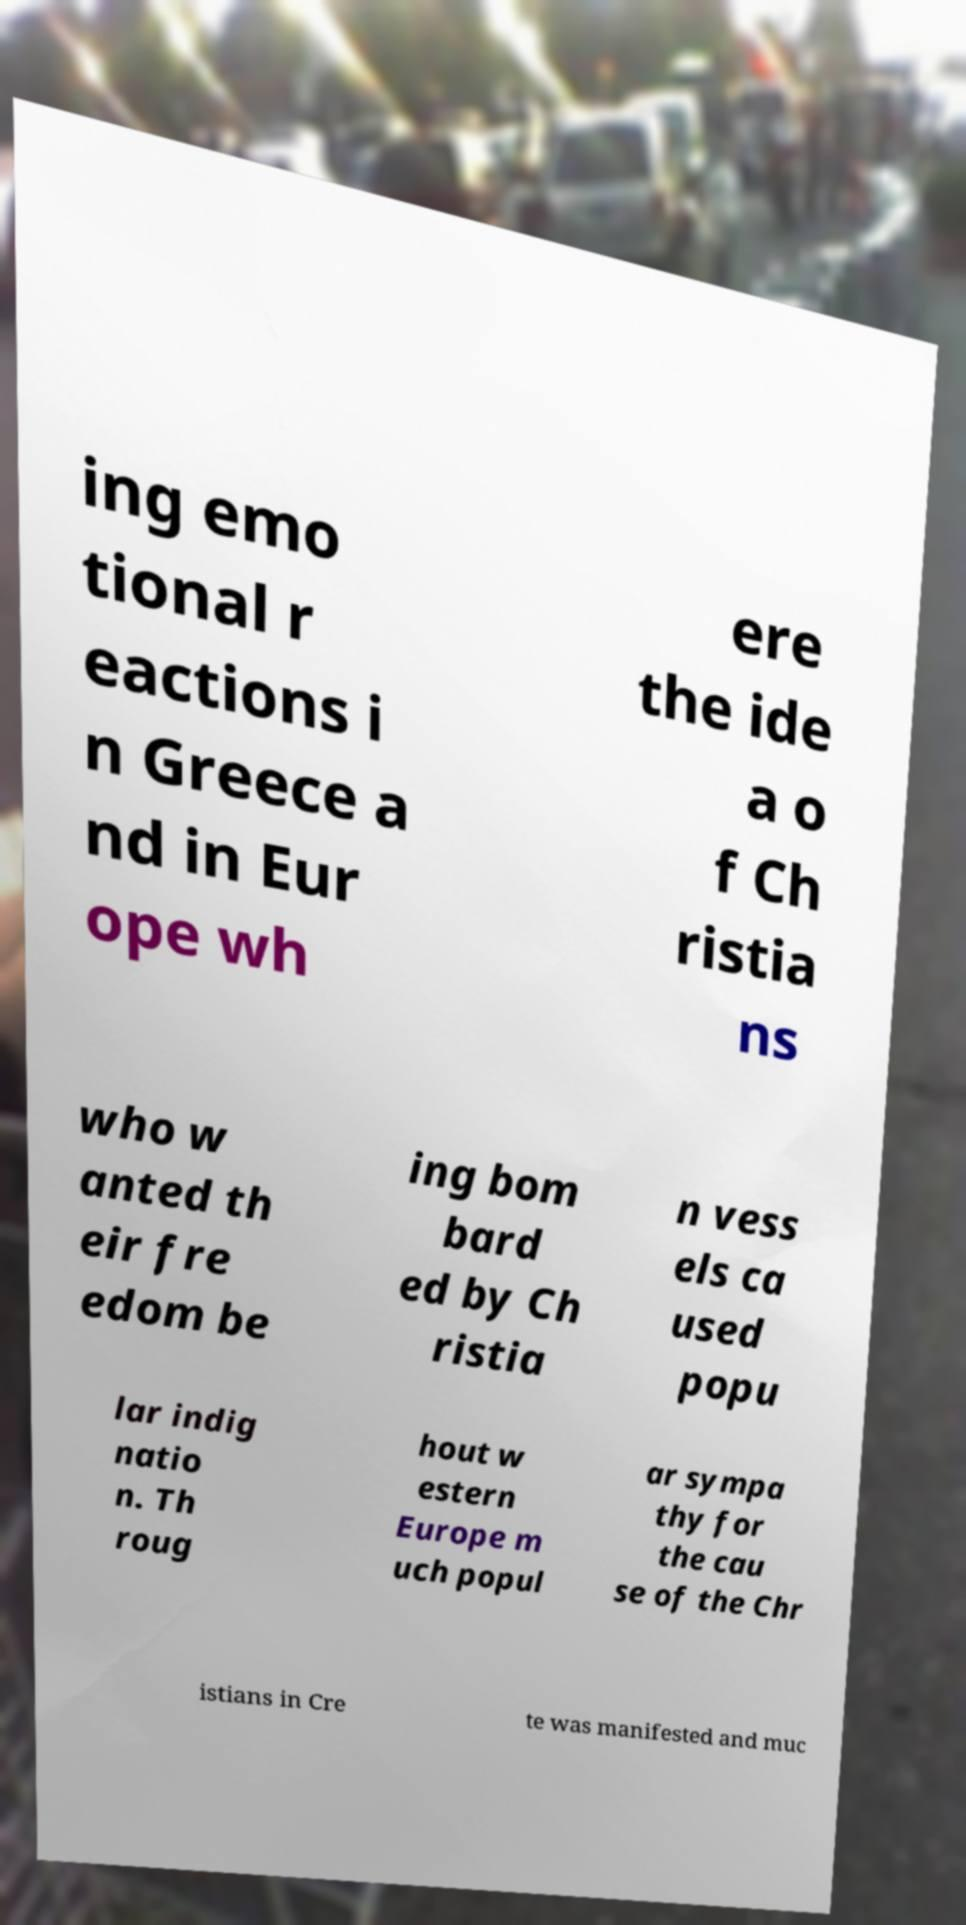There's text embedded in this image that I need extracted. Can you transcribe it verbatim? ing emo tional r eactions i n Greece a nd in Eur ope wh ere the ide a o f Ch ristia ns who w anted th eir fre edom be ing bom bard ed by Ch ristia n vess els ca used popu lar indig natio n. Th roug hout w estern Europe m uch popul ar sympa thy for the cau se of the Chr istians in Cre te was manifested and muc 